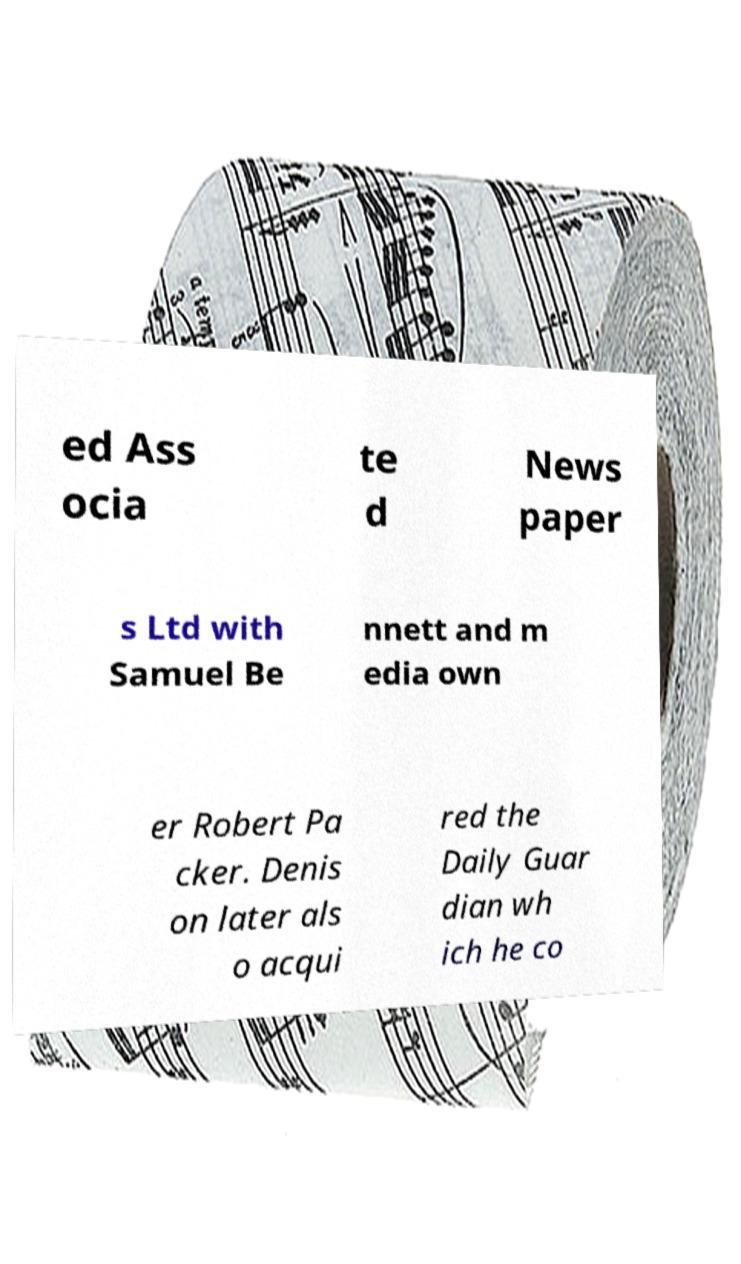Can you accurately transcribe the text from the provided image for me? ed Ass ocia te d News paper s Ltd with Samuel Be nnett and m edia own er Robert Pa cker. Denis on later als o acqui red the Daily Guar dian wh ich he co 